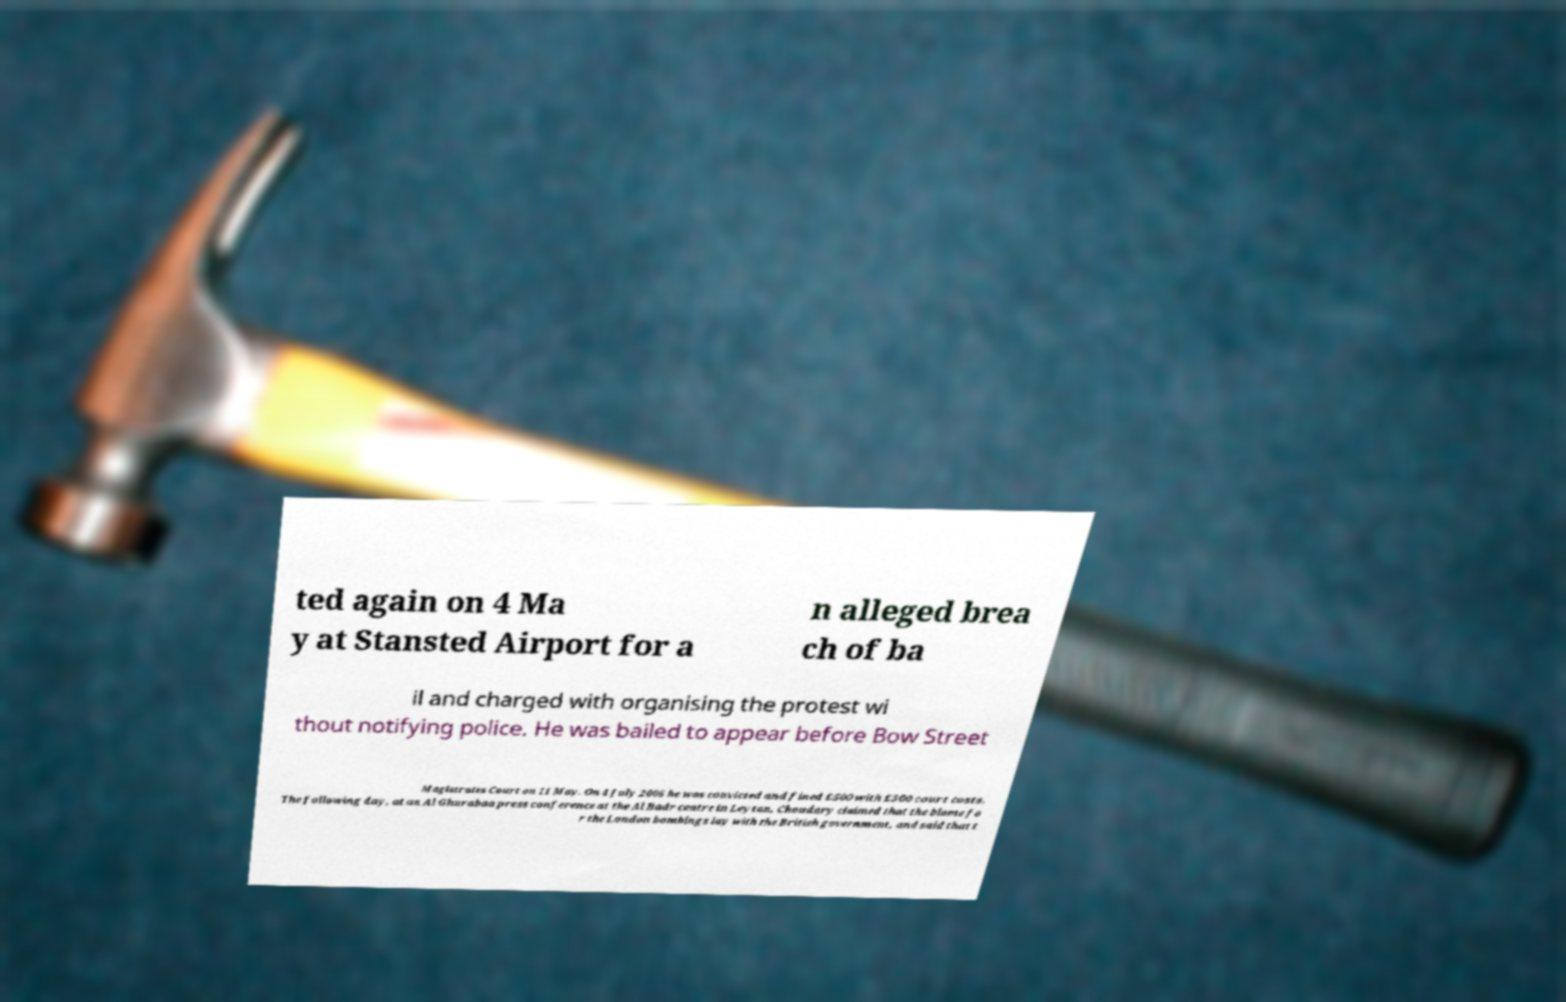Please read and relay the text visible in this image. What does it say? ted again on 4 Ma y at Stansted Airport for a n alleged brea ch of ba il and charged with organising the protest wi thout notifying police. He was bailed to appear before Bow Street Magistrates Court on 11 May. On 4 July 2006 he was convicted and fined £500 with £300 court costs. The following day, at an Al Ghurabaa press conference at the Al Badr centre in Leyton, Choudary claimed that the blame fo r the London bombings lay with the British government, and said that t 